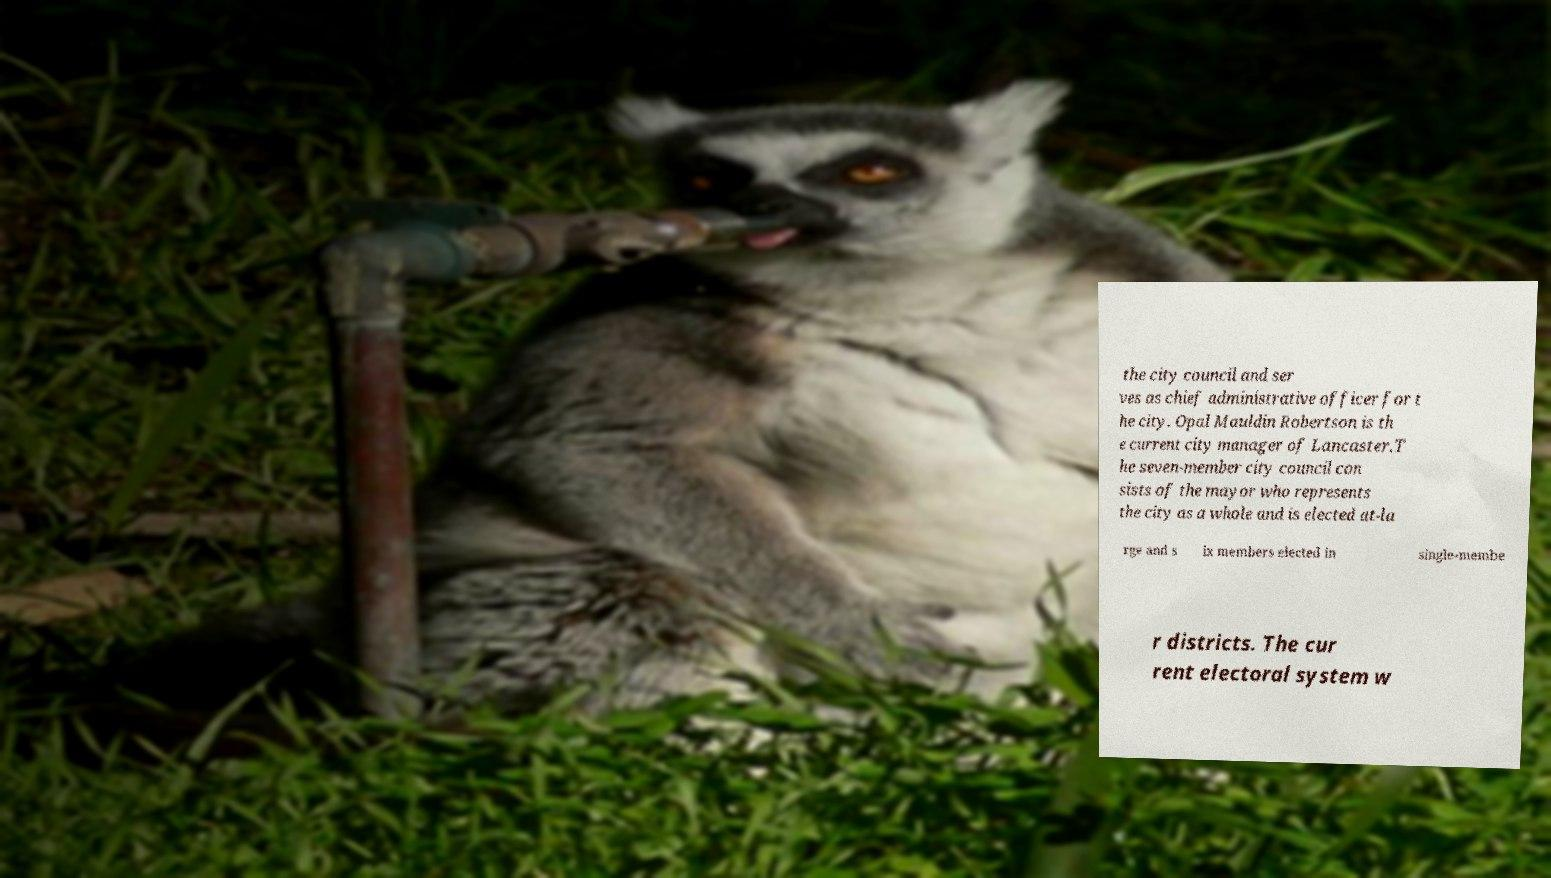For documentation purposes, I need the text within this image transcribed. Could you provide that? the city council and ser ves as chief administrative officer for t he city. Opal Mauldin Robertson is th e current city manager of Lancaster.T he seven-member city council con sists of the mayor who represents the city as a whole and is elected at-la rge and s ix members elected in single-membe r districts. The cur rent electoral system w 